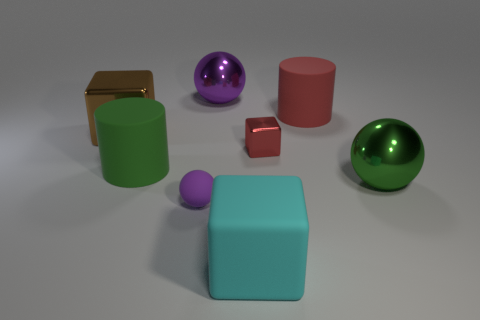Add 2 big green balls. How many objects exist? 10 Subtract all balls. How many objects are left? 5 Add 4 large red rubber cylinders. How many large red rubber cylinders exist? 5 Subtract 0 cyan cylinders. How many objects are left? 8 Subtract all large green cubes. Subtract all green things. How many objects are left? 6 Add 7 tiny purple objects. How many tiny purple objects are left? 8 